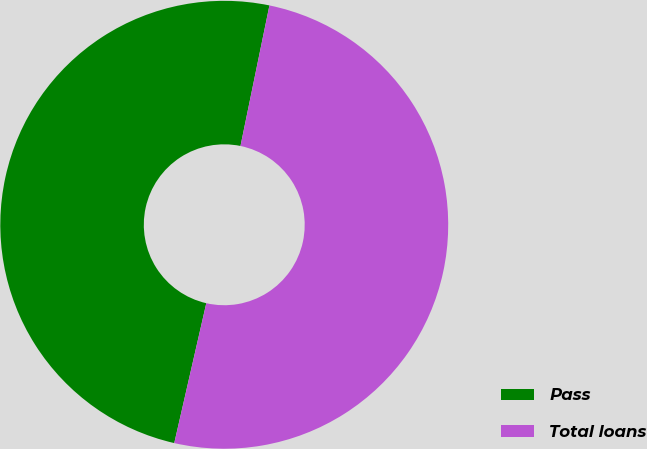<chart> <loc_0><loc_0><loc_500><loc_500><pie_chart><fcel>Pass<fcel>Total loans<nl><fcel>49.65%<fcel>50.35%<nl></chart> 